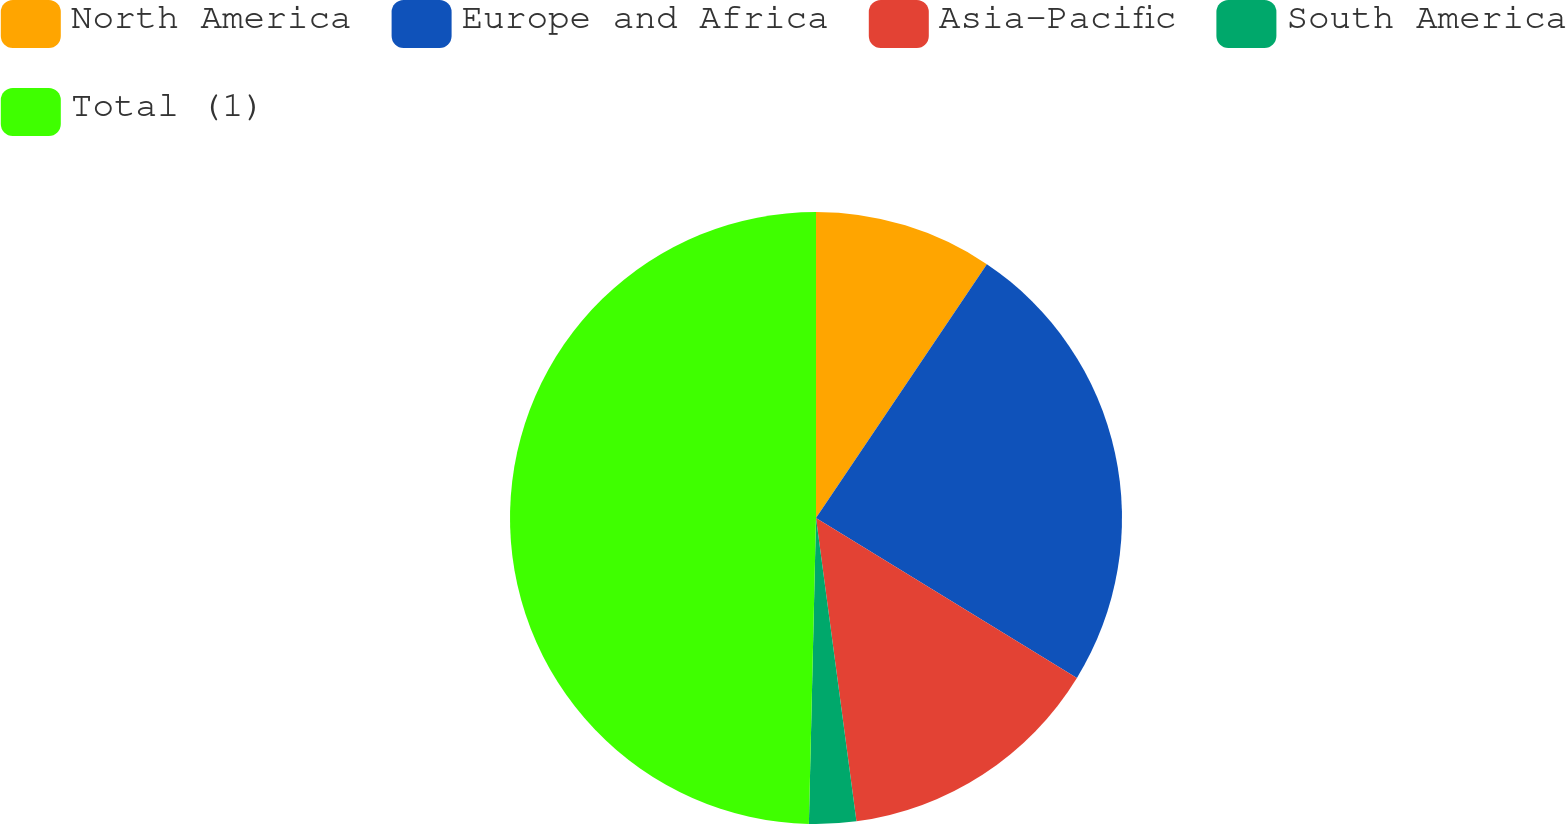Convert chart to OTSL. <chart><loc_0><loc_0><loc_500><loc_500><pie_chart><fcel>North America<fcel>Europe and Africa<fcel>Asia-Pacific<fcel>South America<fcel>Total (1)<nl><fcel>9.43%<fcel>24.32%<fcel>14.14%<fcel>2.48%<fcel>49.63%<nl></chart> 